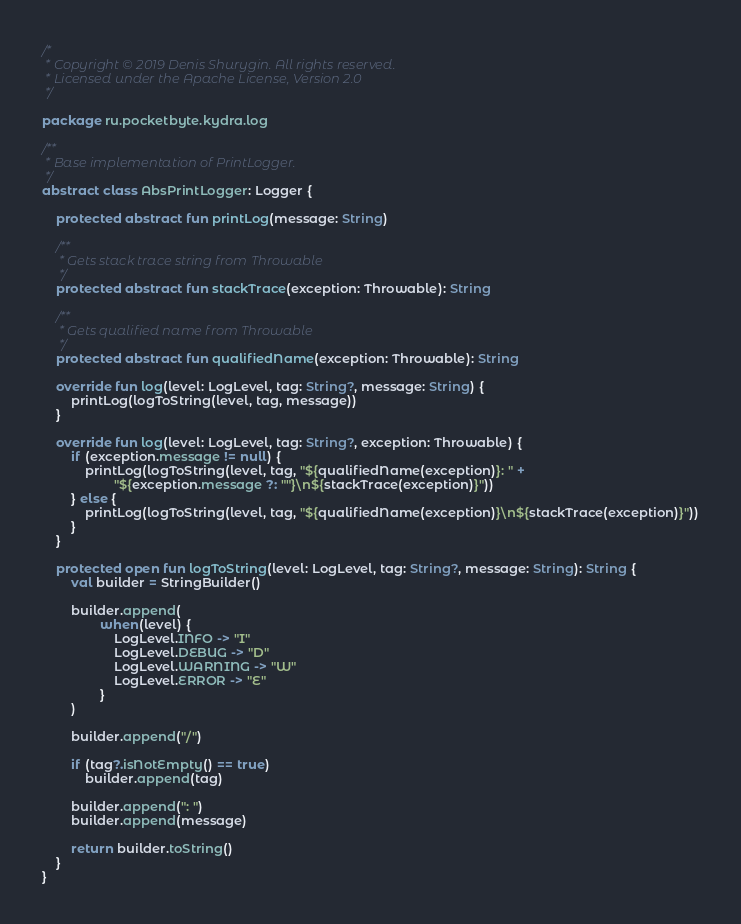<code> <loc_0><loc_0><loc_500><loc_500><_Kotlin_>/*
 * Copyright © 2019 Denis Shurygin. All rights reserved.
 * Licensed under the Apache License, Version 2.0
 */

package ru.pocketbyte.kydra.log

/**
 * Base implementation of PrintLogger.
 */
abstract class AbsPrintLogger: Logger {

    protected abstract fun printLog(message: String)

    /**
     * Gets stack trace string from Throwable
     */
    protected abstract fun stackTrace(exception: Throwable): String

    /**
     * Gets qualified name from Throwable
     */
    protected abstract fun qualifiedName(exception: Throwable): String

    override fun log(level: LogLevel, tag: String?, message: String) {
        printLog(logToString(level, tag, message))
    }

    override fun log(level: LogLevel, tag: String?, exception: Throwable) {
        if (exception.message != null) {
            printLog(logToString(level, tag, "${qualifiedName(exception)}: " +
                    "${exception.message ?: ""}\n${stackTrace(exception)}"))
        } else {
            printLog(logToString(level, tag, "${qualifiedName(exception)}\n${stackTrace(exception)}"))
        }
    }

    protected open fun logToString(level: LogLevel, tag: String?, message: String): String {
        val builder = StringBuilder()

        builder.append(
                when(level) {
                    LogLevel.INFO -> "I"
                    LogLevel.DEBUG -> "D"
                    LogLevel.WARNING -> "W"
                    LogLevel.ERROR -> "E"
                }
        )

        builder.append("/")

        if (tag?.isNotEmpty() == true)
            builder.append(tag)

        builder.append(": ")
        builder.append(message)

        return builder.toString()
    }
}</code> 